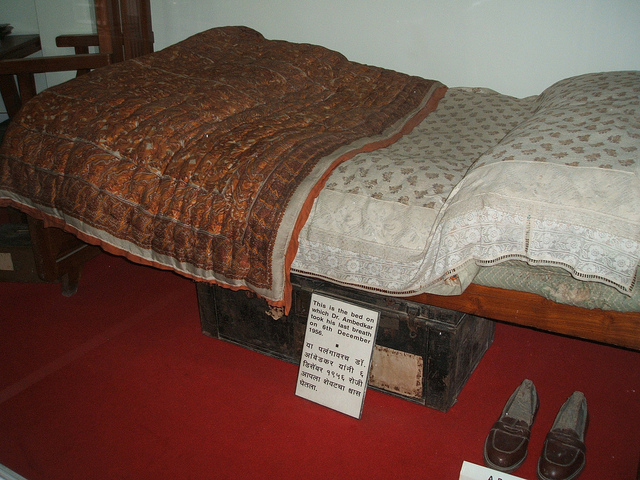Read and extract the text from this image. This on 1055 December 